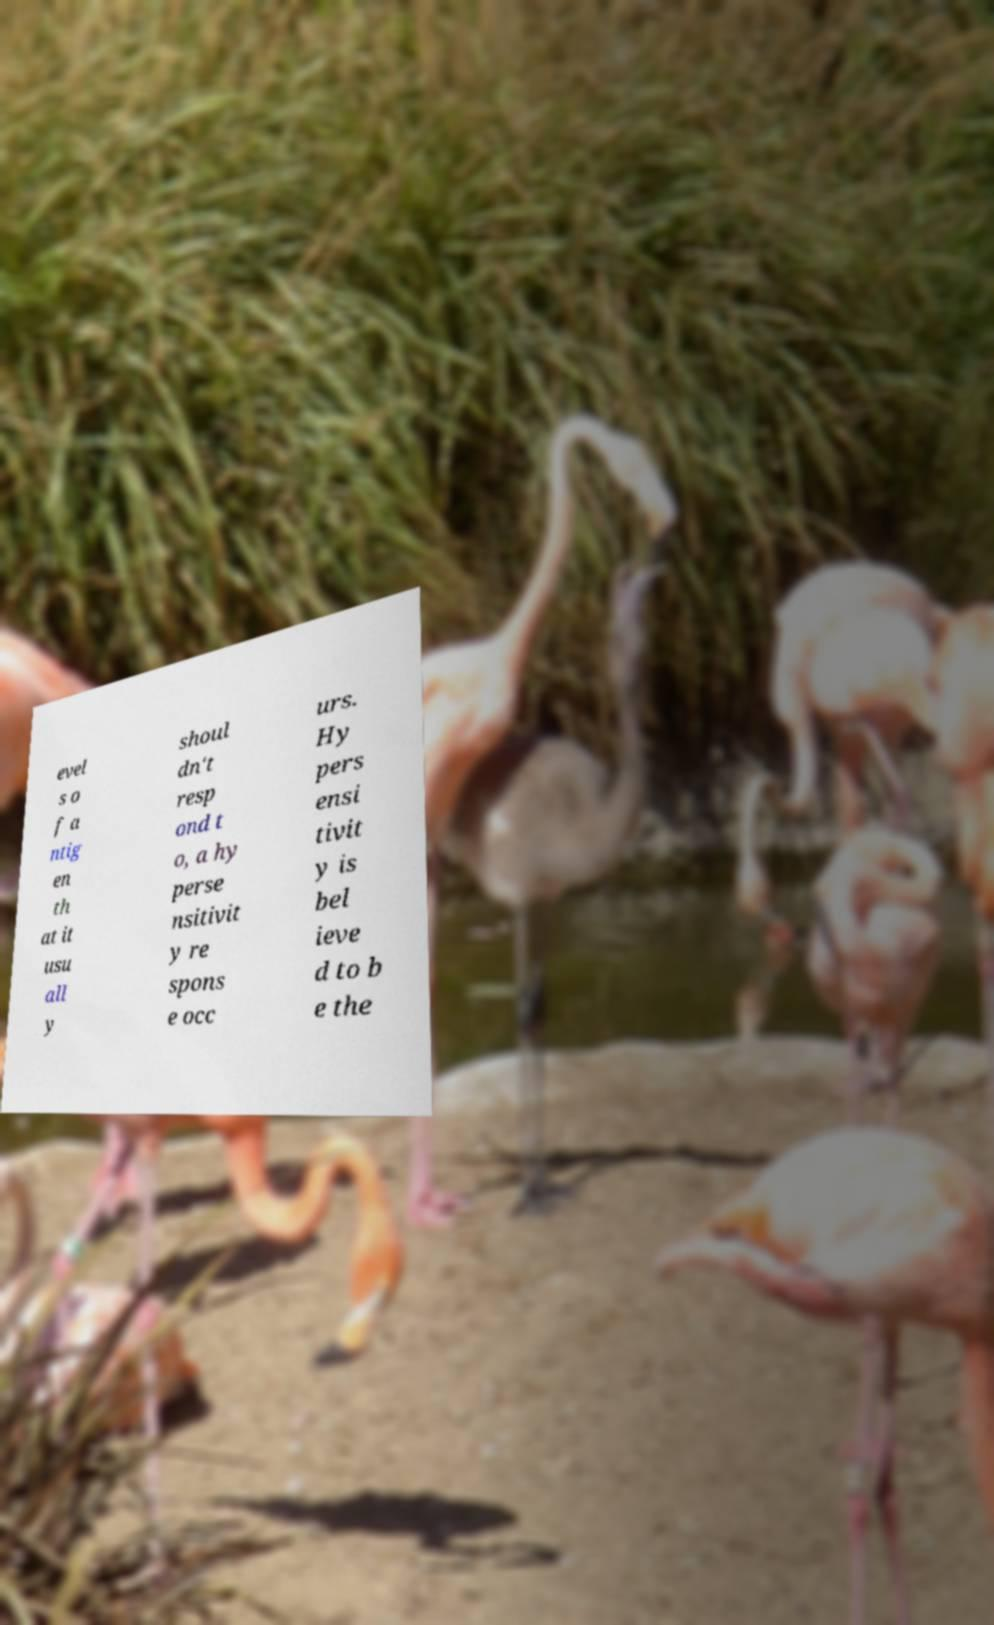Could you extract and type out the text from this image? evel s o f a ntig en th at it usu all y shoul dn't resp ond t o, a hy perse nsitivit y re spons e occ urs. Hy pers ensi tivit y is bel ieve d to b e the 